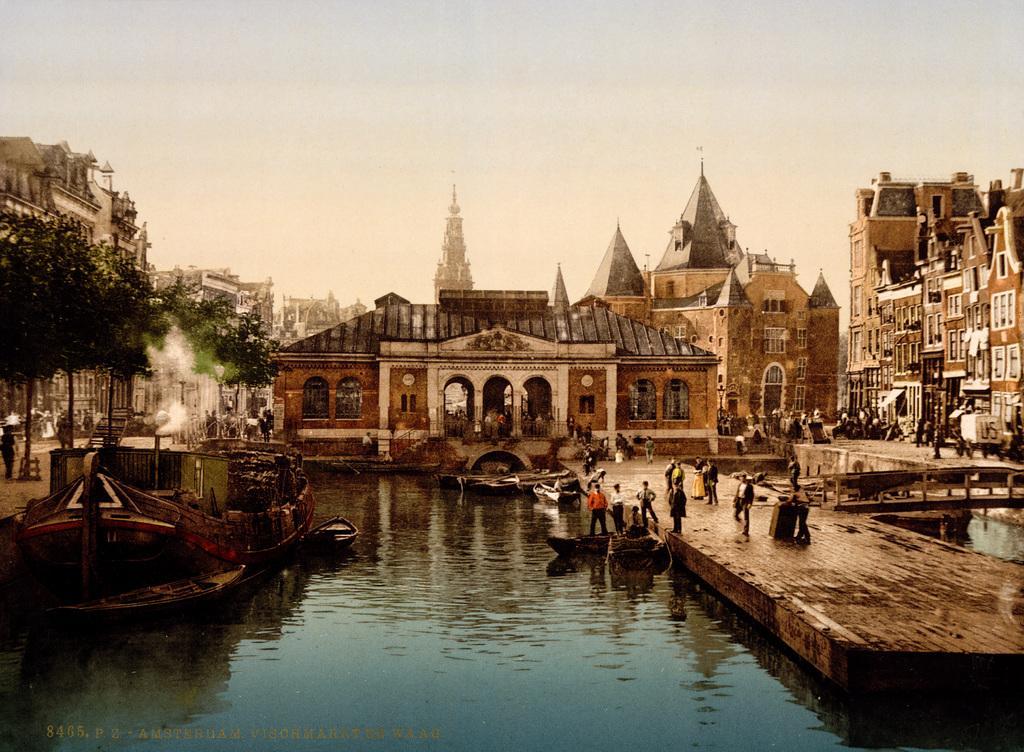Describe this image in one or two sentences. Here we can see water, boats, and few people. There are trees and buildings. In the background there is sky. 